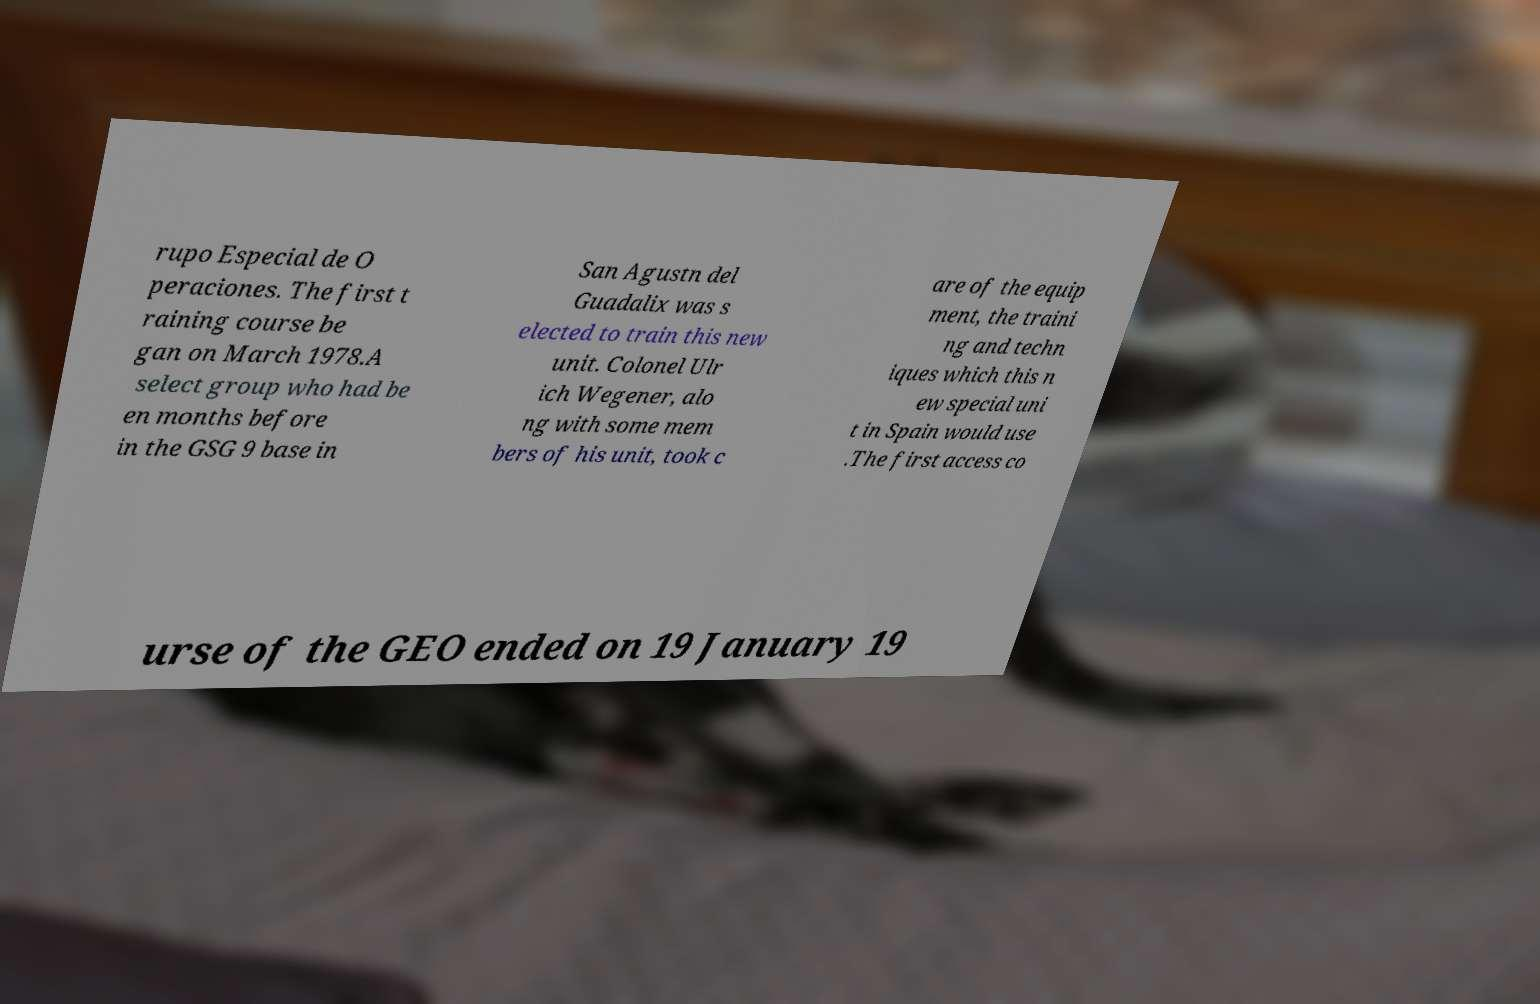There's text embedded in this image that I need extracted. Can you transcribe it verbatim? rupo Especial de O peraciones. The first t raining course be gan on March 1978.A select group who had be en months before in the GSG 9 base in San Agustn del Guadalix was s elected to train this new unit. Colonel Ulr ich Wegener, alo ng with some mem bers of his unit, took c are of the equip ment, the traini ng and techn iques which this n ew special uni t in Spain would use .The first access co urse of the GEO ended on 19 January 19 